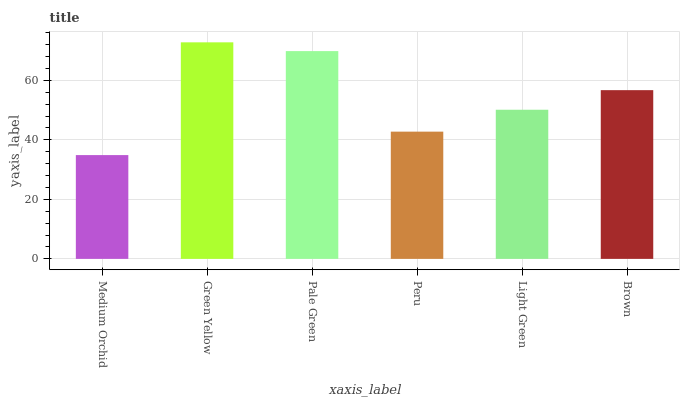Is Medium Orchid the minimum?
Answer yes or no. Yes. Is Green Yellow the maximum?
Answer yes or no. Yes. Is Pale Green the minimum?
Answer yes or no. No. Is Pale Green the maximum?
Answer yes or no. No. Is Green Yellow greater than Pale Green?
Answer yes or no. Yes. Is Pale Green less than Green Yellow?
Answer yes or no. Yes. Is Pale Green greater than Green Yellow?
Answer yes or no. No. Is Green Yellow less than Pale Green?
Answer yes or no. No. Is Brown the high median?
Answer yes or no. Yes. Is Light Green the low median?
Answer yes or no. Yes. Is Light Green the high median?
Answer yes or no. No. Is Medium Orchid the low median?
Answer yes or no. No. 